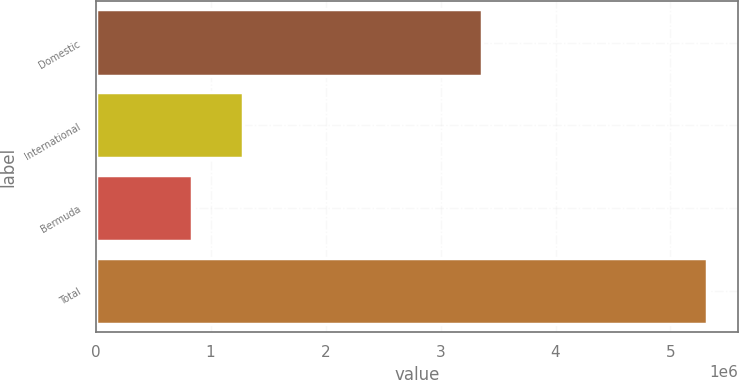<chart> <loc_0><loc_0><loc_500><loc_500><bar_chart><fcel>Domestic<fcel>International<fcel>Bermuda<fcel>Total<nl><fcel>3.36338e+06<fcel>1.28621e+06<fcel>837964<fcel>5.32047e+06<nl></chart> 